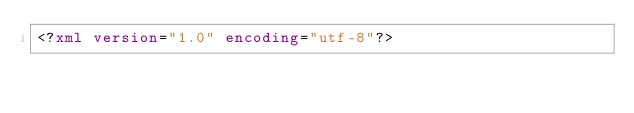Convert code to text. <code><loc_0><loc_0><loc_500><loc_500><_XML_><?xml version="1.0" encoding="utf-8"?></code> 